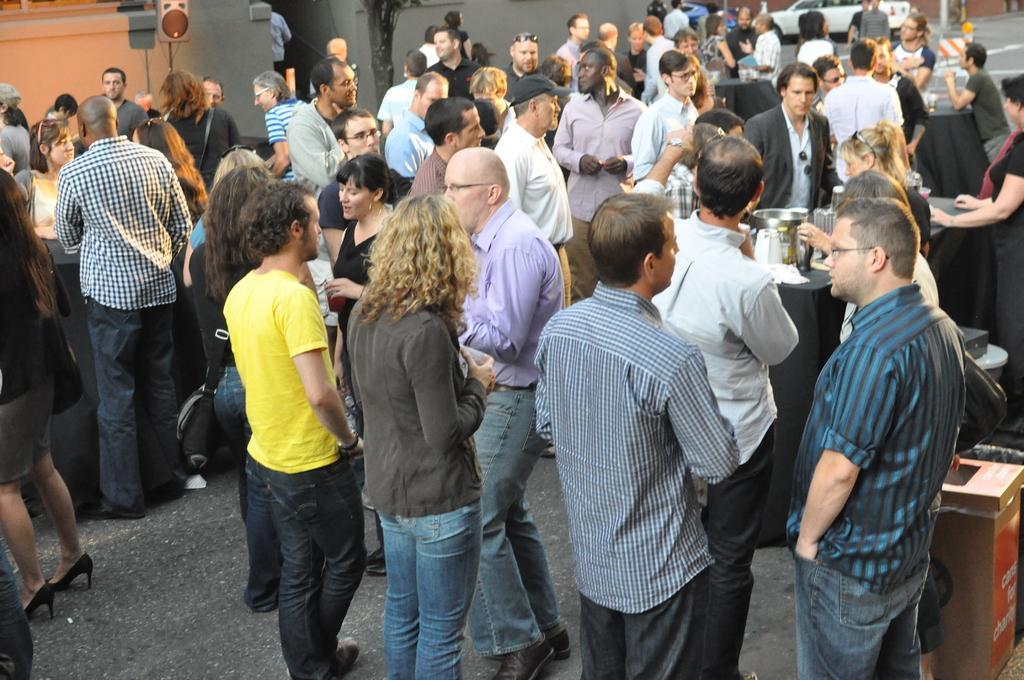How would you summarize this image in a sentence or two? In this picture we can see a group of people,vehicles on the road. 